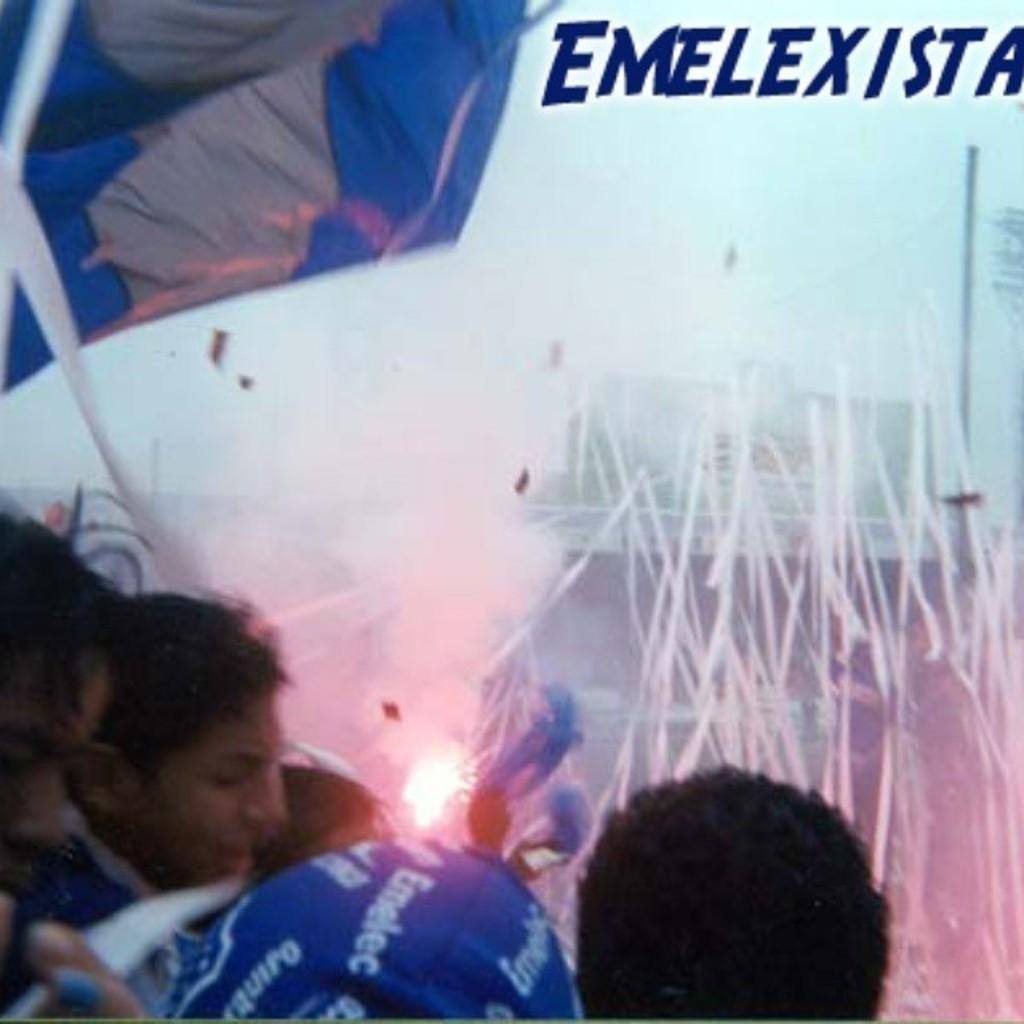What is happening in the image? There is a group of people standing in the image. What can be seen in the background of the image? In the background, there is cloth, a pole, a building, and sky visible. Can you describe the setting of the image? The setting of the image includes a group of people standing in front of a background that features cloth, a pole, a building, and sky. What is the rate of the pie being consumed by the group of people in the image? There is no pie present in the image, so it is not possible to determine the rate at which it would be consumed. 